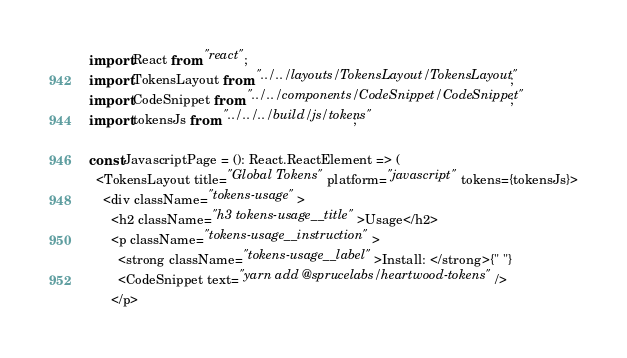<code> <loc_0><loc_0><loc_500><loc_500><_TypeScript_>import React from "react";
import TokensLayout from "../../layouts/TokensLayout/TokensLayout";
import CodeSnippet from "../../components/CodeSnippet/CodeSnippet";
import tokensJs from "../../../build/js/tokens";

const JavascriptPage = (): React.ReactElement => (
  <TokensLayout title="Global Tokens" platform="javascript" tokens={tokensJs}>
    <div className="tokens-usage">
      <h2 className="h3 tokens-usage__title">Usage</h2>
      <p className="tokens-usage__instruction">
        <strong className="tokens-usage__label">Install: </strong>{" "}
        <CodeSnippet text="yarn add @sprucelabs/heartwood-tokens" />
      </p></code> 